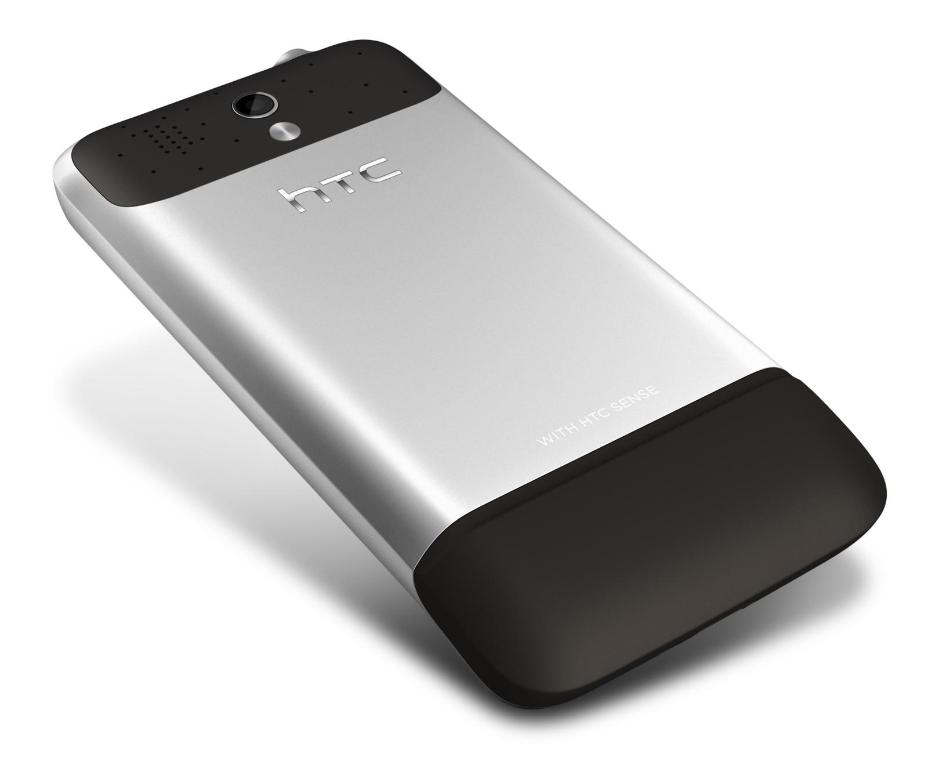What features can be observed on the back side of this HTC phone? The back side of the HTC phone shows a rear camera positioned at the center near the top, accompanied by microphone holes and prominently displaying its silver and black finish marked with the HTC logo and the 'with HTC sense' label. 